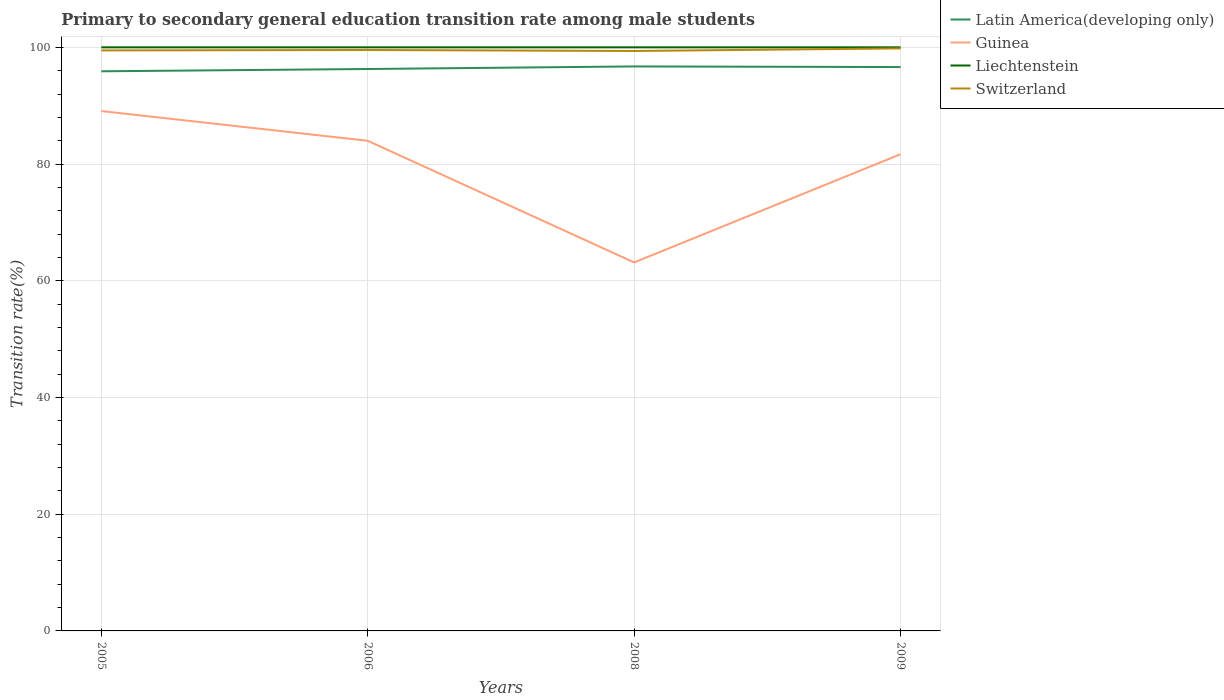Does the line corresponding to Latin America(developing only) intersect with the line corresponding to Guinea?
Provide a short and direct response. No. Across all years, what is the maximum transition rate in Latin America(developing only)?
Give a very brief answer. 95.89. In which year was the transition rate in Latin America(developing only) maximum?
Offer a terse response. 2005. What is the total transition rate in Switzerland in the graph?
Offer a very short reply. -0.27. What is the difference between the highest and the second highest transition rate in Guinea?
Offer a terse response. 25.94. How many lines are there?
Provide a short and direct response. 4. How many years are there in the graph?
Provide a short and direct response. 4. What is the difference between two consecutive major ticks on the Y-axis?
Your answer should be very brief. 20. Are the values on the major ticks of Y-axis written in scientific E-notation?
Provide a short and direct response. No. Does the graph contain any zero values?
Provide a short and direct response. No. What is the title of the graph?
Provide a succinct answer. Primary to secondary general education transition rate among male students. What is the label or title of the Y-axis?
Offer a very short reply. Transition rate(%). What is the Transition rate(%) in Latin America(developing only) in 2005?
Offer a very short reply. 95.89. What is the Transition rate(%) in Guinea in 2005?
Your response must be concise. 89.08. What is the Transition rate(%) in Switzerland in 2005?
Your answer should be very brief. 99.47. What is the Transition rate(%) in Latin America(developing only) in 2006?
Offer a very short reply. 96.29. What is the Transition rate(%) of Guinea in 2006?
Give a very brief answer. 83.99. What is the Transition rate(%) of Switzerland in 2006?
Your answer should be compact. 99.54. What is the Transition rate(%) in Latin America(developing only) in 2008?
Give a very brief answer. 96.73. What is the Transition rate(%) of Guinea in 2008?
Make the answer very short. 63.14. What is the Transition rate(%) in Liechtenstein in 2008?
Keep it short and to the point. 100. What is the Transition rate(%) of Switzerland in 2008?
Provide a succinct answer. 99.38. What is the Transition rate(%) of Latin America(developing only) in 2009?
Offer a very short reply. 96.62. What is the Transition rate(%) in Guinea in 2009?
Provide a short and direct response. 81.68. What is the Transition rate(%) in Switzerland in 2009?
Your response must be concise. 99.81. Across all years, what is the maximum Transition rate(%) of Latin America(developing only)?
Your answer should be very brief. 96.73. Across all years, what is the maximum Transition rate(%) in Guinea?
Provide a short and direct response. 89.08. Across all years, what is the maximum Transition rate(%) in Liechtenstein?
Provide a succinct answer. 100. Across all years, what is the maximum Transition rate(%) of Switzerland?
Provide a short and direct response. 99.81. Across all years, what is the minimum Transition rate(%) in Latin America(developing only)?
Ensure brevity in your answer.  95.89. Across all years, what is the minimum Transition rate(%) in Guinea?
Provide a succinct answer. 63.14. Across all years, what is the minimum Transition rate(%) in Liechtenstein?
Make the answer very short. 100. Across all years, what is the minimum Transition rate(%) in Switzerland?
Offer a terse response. 99.38. What is the total Transition rate(%) in Latin America(developing only) in the graph?
Offer a very short reply. 385.53. What is the total Transition rate(%) of Guinea in the graph?
Provide a short and direct response. 317.89. What is the total Transition rate(%) of Switzerland in the graph?
Provide a short and direct response. 398.2. What is the difference between the Transition rate(%) in Latin America(developing only) in 2005 and that in 2006?
Keep it short and to the point. -0.39. What is the difference between the Transition rate(%) of Guinea in 2005 and that in 2006?
Offer a very short reply. 5.09. What is the difference between the Transition rate(%) in Liechtenstein in 2005 and that in 2006?
Offer a terse response. 0. What is the difference between the Transition rate(%) in Switzerland in 2005 and that in 2006?
Provide a short and direct response. -0.07. What is the difference between the Transition rate(%) in Latin America(developing only) in 2005 and that in 2008?
Provide a succinct answer. -0.83. What is the difference between the Transition rate(%) of Guinea in 2005 and that in 2008?
Your answer should be compact. 25.94. What is the difference between the Transition rate(%) of Switzerland in 2005 and that in 2008?
Provide a succinct answer. 0.1. What is the difference between the Transition rate(%) in Latin America(developing only) in 2005 and that in 2009?
Offer a terse response. -0.73. What is the difference between the Transition rate(%) in Guinea in 2005 and that in 2009?
Keep it short and to the point. 7.4. What is the difference between the Transition rate(%) of Liechtenstein in 2005 and that in 2009?
Make the answer very short. 0. What is the difference between the Transition rate(%) of Switzerland in 2005 and that in 2009?
Your answer should be compact. -0.34. What is the difference between the Transition rate(%) in Latin America(developing only) in 2006 and that in 2008?
Your answer should be compact. -0.44. What is the difference between the Transition rate(%) in Guinea in 2006 and that in 2008?
Keep it short and to the point. 20.84. What is the difference between the Transition rate(%) of Liechtenstein in 2006 and that in 2008?
Your answer should be very brief. 0. What is the difference between the Transition rate(%) of Switzerland in 2006 and that in 2008?
Your answer should be compact. 0.17. What is the difference between the Transition rate(%) in Latin America(developing only) in 2006 and that in 2009?
Your answer should be compact. -0.34. What is the difference between the Transition rate(%) in Guinea in 2006 and that in 2009?
Provide a short and direct response. 2.3. What is the difference between the Transition rate(%) of Switzerland in 2006 and that in 2009?
Give a very brief answer. -0.27. What is the difference between the Transition rate(%) in Latin America(developing only) in 2008 and that in 2009?
Provide a succinct answer. 0.1. What is the difference between the Transition rate(%) of Guinea in 2008 and that in 2009?
Your answer should be compact. -18.54. What is the difference between the Transition rate(%) of Liechtenstein in 2008 and that in 2009?
Keep it short and to the point. 0. What is the difference between the Transition rate(%) of Switzerland in 2008 and that in 2009?
Make the answer very short. -0.44. What is the difference between the Transition rate(%) in Latin America(developing only) in 2005 and the Transition rate(%) in Guinea in 2006?
Ensure brevity in your answer.  11.91. What is the difference between the Transition rate(%) in Latin America(developing only) in 2005 and the Transition rate(%) in Liechtenstein in 2006?
Your response must be concise. -4.11. What is the difference between the Transition rate(%) of Latin America(developing only) in 2005 and the Transition rate(%) of Switzerland in 2006?
Give a very brief answer. -3.65. What is the difference between the Transition rate(%) of Guinea in 2005 and the Transition rate(%) of Liechtenstein in 2006?
Make the answer very short. -10.92. What is the difference between the Transition rate(%) of Guinea in 2005 and the Transition rate(%) of Switzerland in 2006?
Your response must be concise. -10.46. What is the difference between the Transition rate(%) in Liechtenstein in 2005 and the Transition rate(%) in Switzerland in 2006?
Your response must be concise. 0.46. What is the difference between the Transition rate(%) of Latin America(developing only) in 2005 and the Transition rate(%) of Guinea in 2008?
Your response must be concise. 32.75. What is the difference between the Transition rate(%) of Latin America(developing only) in 2005 and the Transition rate(%) of Liechtenstein in 2008?
Offer a very short reply. -4.11. What is the difference between the Transition rate(%) in Latin America(developing only) in 2005 and the Transition rate(%) in Switzerland in 2008?
Ensure brevity in your answer.  -3.48. What is the difference between the Transition rate(%) of Guinea in 2005 and the Transition rate(%) of Liechtenstein in 2008?
Your answer should be compact. -10.92. What is the difference between the Transition rate(%) in Guinea in 2005 and the Transition rate(%) in Switzerland in 2008?
Provide a succinct answer. -10.3. What is the difference between the Transition rate(%) of Liechtenstein in 2005 and the Transition rate(%) of Switzerland in 2008?
Offer a very short reply. 0.62. What is the difference between the Transition rate(%) in Latin America(developing only) in 2005 and the Transition rate(%) in Guinea in 2009?
Give a very brief answer. 14.21. What is the difference between the Transition rate(%) of Latin America(developing only) in 2005 and the Transition rate(%) of Liechtenstein in 2009?
Offer a very short reply. -4.11. What is the difference between the Transition rate(%) of Latin America(developing only) in 2005 and the Transition rate(%) of Switzerland in 2009?
Make the answer very short. -3.92. What is the difference between the Transition rate(%) in Guinea in 2005 and the Transition rate(%) in Liechtenstein in 2009?
Offer a terse response. -10.92. What is the difference between the Transition rate(%) of Guinea in 2005 and the Transition rate(%) of Switzerland in 2009?
Offer a terse response. -10.73. What is the difference between the Transition rate(%) of Liechtenstein in 2005 and the Transition rate(%) of Switzerland in 2009?
Provide a short and direct response. 0.19. What is the difference between the Transition rate(%) of Latin America(developing only) in 2006 and the Transition rate(%) of Guinea in 2008?
Give a very brief answer. 33.14. What is the difference between the Transition rate(%) in Latin America(developing only) in 2006 and the Transition rate(%) in Liechtenstein in 2008?
Give a very brief answer. -3.71. What is the difference between the Transition rate(%) in Latin America(developing only) in 2006 and the Transition rate(%) in Switzerland in 2008?
Give a very brief answer. -3.09. What is the difference between the Transition rate(%) in Guinea in 2006 and the Transition rate(%) in Liechtenstein in 2008?
Offer a very short reply. -16.01. What is the difference between the Transition rate(%) in Guinea in 2006 and the Transition rate(%) in Switzerland in 2008?
Keep it short and to the point. -15.39. What is the difference between the Transition rate(%) in Liechtenstein in 2006 and the Transition rate(%) in Switzerland in 2008?
Ensure brevity in your answer.  0.62. What is the difference between the Transition rate(%) in Latin America(developing only) in 2006 and the Transition rate(%) in Guinea in 2009?
Your answer should be compact. 14.6. What is the difference between the Transition rate(%) in Latin America(developing only) in 2006 and the Transition rate(%) in Liechtenstein in 2009?
Give a very brief answer. -3.71. What is the difference between the Transition rate(%) in Latin America(developing only) in 2006 and the Transition rate(%) in Switzerland in 2009?
Provide a succinct answer. -3.53. What is the difference between the Transition rate(%) in Guinea in 2006 and the Transition rate(%) in Liechtenstein in 2009?
Make the answer very short. -16.01. What is the difference between the Transition rate(%) in Guinea in 2006 and the Transition rate(%) in Switzerland in 2009?
Offer a terse response. -15.83. What is the difference between the Transition rate(%) in Liechtenstein in 2006 and the Transition rate(%) in Switzerland in 2009?
Offer a terse response. 0.19. What is the difference between the Transition rate(%) in Latin America(developing only) in 2008 and the Transition rate(%) in Guinea in 2009?
Provide a succinct answer. 15.04. What is the difference between the Transition rate(%) of Latin America(developing only) in 2008 and the Transition rate(%) of Liechtenstein in 2009?
Give a very brief answer. -3.27. What is the difference between the Transition rate(%) of Latin America(developing only) in 2008 and the Transition rate(%) of Switzerland in 2009?
Provide a succinct answer. -3.09. What is the difference between the Transition rate(%) in Guinea in 2008 and the Transition rate(%) in Liechtenstein in 2009?
Make the answer very short. -36.86. What is the difference between the Transition rate(%) in Guinea in 2008 and the Transition rate(%) in Switzerland in 2009?
Your response must be concise. -36.67. What is the difference between the Transition rate(%) of Liechtenstein in 2008 and the Transition rate(%) of Switzerland in 2009?
Your response must be concise. 0.19. What is the average Transition rate(%) of Latin America(developing only) per year?
Offer a terse response. 96.38. What is the average Transition rate(%) in Guinea per year?
Make the answer very short. 79.47. What is the average Transition rate(%) of Switzerland per year?
Provide a short and direct response. 99.55. In the year 2005, what is the difference between the Transition rate(%) of Latin America(developing only) and Transition rate(%) of Guinea?
Offer a terse response. 6.81. In the year 2005, what is the difference between the Transition rate(%) in Latin America(developing only) and Transition rate(%) in Liechtenstein?
Keep it short and to the point. -4.11. In the year 2005, what is the difference between the Transition rate(%) of Latin America(developing only) and Transition rate(%) of Switzerland?
Your answer should be very brief. -3.58. In the year 2005, what is the difference between the Transition rate(%) in Guinea and Transition rate(%) in Liechtenstein?
Offer a terse response. -10.92. In the year 2005, what is the difference between the Transition rate(%) in Guinea and Transition rate(%) in Switzerland?
Provide a succinct answer. -10.39. In the year 2005, what is the difference between the Transition rate(%) in Liechtenstein and Transition rate(%) in Switzerland?
Keep it short and to the point. 0.53. In the year 2006, what is the difference between the Transition rate(%) in Latin America(developing only) and Transition rate(%) in Guinea?
Your response must be concise. 12.3. In the year 2006, what is the difference between the Transition rate(%) in Latin America(developing only) and Transition rate(%) in Liechtenstein?
Make the answer very short. -3.71. In the year 2006, what is the difference between the Transition rate(%) in Latin America(developing only) and Transition rate(%) in Switzerland?
Offer a very short reply. -3.26. In the year 2006, what is the difference between the Transition rate(%) of Guinea and Transition rate(%) of Liechtenstein?
Keep it short and to the point. -16.01. In the year 2006, what is the difference between the Transition rate(%) of Guinea and Transition rate(%) of Switzerland?
Make the answer very short. -15.56. In the year 2006, what is the difference between the Transition rate(%) of Liechtenstein and Transition rate(%) of Switzerland?
Provide a succinct answer. 0.46. In the year 2008, what is the difference between the Transition rate(%) of Latin America(developing only) and Transition rate(%) of Guinea?
Make the answer very short. 33.58. In the year 2008, what is the difference between the Transition rate(%) in Latin America(developing only) and Transition rate(%) in Liechtenstein?
Ensure brevity in your answer.  -3.27. In the year 2008, what is the difference between the Transition rate(%) in Latin America(developing only) and Transition rate(%) in Switzerland?
Your answer should be compact. -2.65. In the year 2008, what is the difference between the Transition rate(%) in Guinea and Transition rate(%) in Liechtenstein?
Your answer should be very brief. -36.86. In the year 2008, what is the difference between the Transition rate(%) in Guinea and Transition rate(%) in Switzerland?
Keep it short and to the point. -36.23. In the year 2008, what is the difference between the Transition rate(%) of Liechtenstein and Transition rate(%) of Switzerland?
Make the answer very short. 0.62. In the year 2009, what is the difference between the Transition rate(%) of Latin America(developing only) and Transition rate(%) of Guinea?
Provide a short and direct response. 14.94. In the year 2009, what is the difference between the Transition rate(%) in Latin America(developing only) and Transition rate(%) in Liechtenstein?
Keep it short and to the point. -3.38. In the year 2009, what is the difference between the Transition rate(%) of Latin America(developing only) and Transition rate(%) of Switzerland?
Offer a terse response. -3.19. In the year 2009, what is the difference between the Transition rate(%) of Guinea and Transition rate(%) of Liechtenstein?
Provide a succinct answer. -18.32. In the year 2009, what is the difference between the Transition rate(%) of Guinea and Transition rate(%) of Switzerland?
Give a very brief answer. -18.13. In the year 2009, what is the difference between the Transition rate(%) in Liechtenstein and Transition rate(%) in Switzerland?
Your answer should be very brief. 0.19. What is the ratio of the Transition rate(%) of Latin America(developing only) in 2005 to that in 2006?
Your answer should be compact. 1. What is the ratio of the Transition rate(%) of Guinea in 2005 to that in 2006?
Ensure brevity in your answer.  1.06. What is the ratio of the Transition rate(%) of Switzerland in 2005 to that in 2006?
Provide a short and direct response. 1. What is the ratio of the Transition rate(%) of Guinea in 2005 to that in 2008?
Provide a short and direct response. 1.41. What is the ratio of the Transition rate(%) in Latin America(developing only) in 2005 to that in 2009?
Offer a terse response. 0.99. What is the ratio of the Transition rate(%) in Guinea in 2005 to that in 2009?
Your answer should be very brief. 1.09. What is the ratio of the Transition rate(%) of Switzerland in 2005 to that in 2009?
Provide a short and direct response. 1. What is the ratio of the Transition rate(%) in Latin America(developing only) in 2006 to that in 2008?
Your response must be concise. 1. What is the ratio of the Transition rate(%) in Guinea in 2006 to that in 2008?
Provide a short and direct response. 1.33. What is the ratio of the Transition rate(%) of Liechtenstein in 2006 to that in 2008?
Your answer should be compact. 1. What is the ratio of the Transition rate(%) of Guinea in 2006 to that in 2009?
Offer a very short reply. 1.03. What is the ratio of the Transition rate(%) of Switzerland in 2006 to that in 2009?
Make the answer very short. 1. What is the ratio of the Transition rate(%) of Guinea in 2008 to that in 2009?
Provide a short and direct response. 0.77. What is the ratio of the Transition rate(%) of Switzerland in 2008 to that in 2009?
Provide a succinct answer. 1. What is the difference between the highest and the second highest Transition rate(%) of Latin America(developing only)?
Your response must be concise. 0.1. What is the difference between the highest and the second highest Transition rate(%) of Guinea?
Your answer should be compact. 5.09. What is the difference between the highest and the second highest Transition rate(%) in Liechtenstein?
Your answer should be very brief. 0. What is the difference between the highest and the second highest Transition rate(%) in Switzerland?
Give a very brief answer. 0.27. What is the difference between the highest and the lowest Transition rate(%) in Latin America(developing only)?
Give a very brief answer. 0.83. What is the difference between the highest and the lowest Transition rate(%) of Guinea?
Keep it short and to the point. 25.94. What is the difference between the highest and the lowest Transition rate(%) of Liechtenstein?
Make the answer very short. 0. What is the difference between the highest and the lowest Transition rate(%) in Switzerland?
Give a very brief answer. 0.44. 